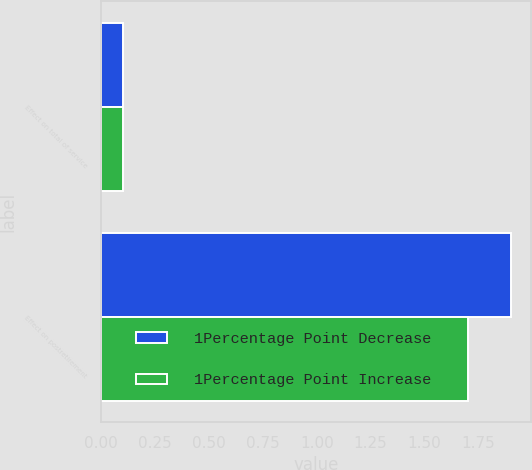Convert chart to OTSL. <chart><loc_0><loc_0><loc_500><loc_500><stacked_bar_chart><ecel><fcel>Effect on total of service<fcel>Effect on postretirement<nl><fcel>1Percentage Point Decrease<fcel>0.1<fcel>1.9<nl><fcel>1Percentage Point Increase<fcel>0.1<fcel>1.7<nl></chart> 